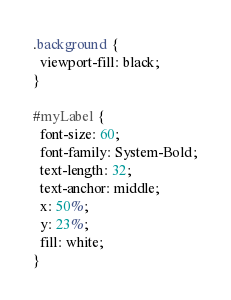<code> <loc_0><loc_0><loc_500><loc_500><_CSS_>.background {
  viewport-fill: black;
}

#myLabel {
  font-size: 60;
  font-family: System-Bold;
  text-length: 32;
  text-anchor: middle;
  x: 50%;
  y: 23%;
  fill: white;
}</code> 